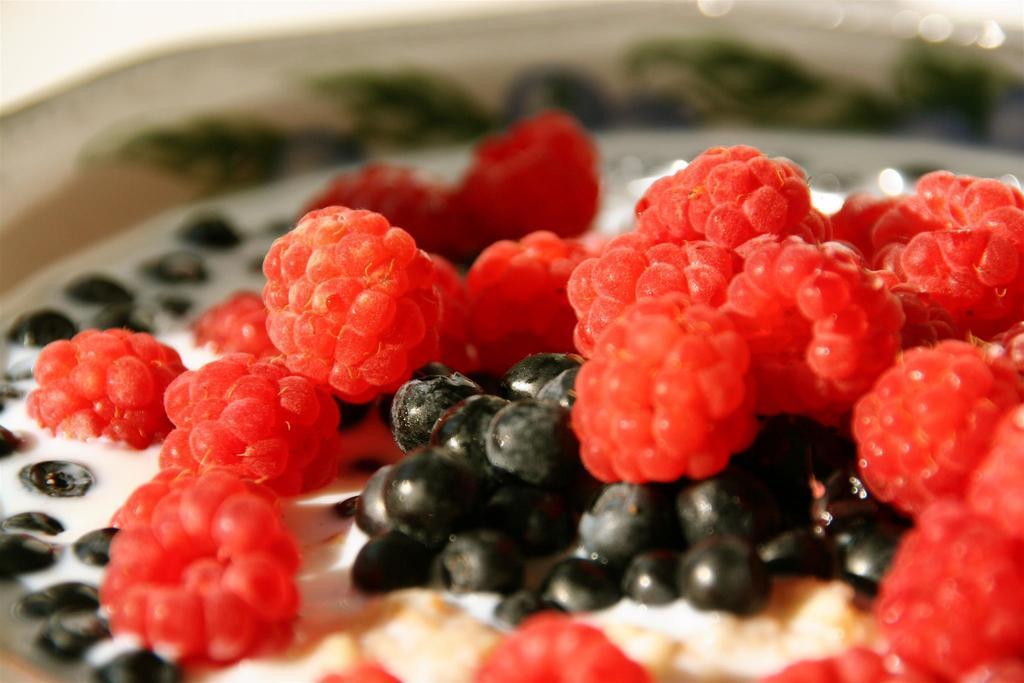How would you summarize this image in a sentence or two? In this image I see the red and black color fruits in this white color liquid. I see that it is blurred in the background. 